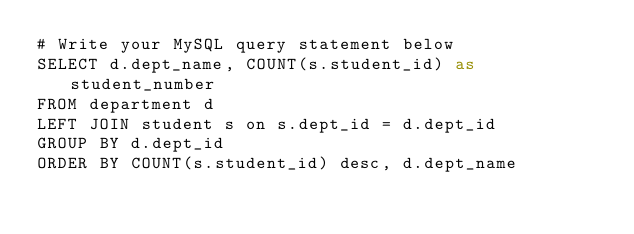<code> <loc_0><loc_0><loc_500><loc_500><_SQL_># Write your MySQL query statement below
SELECT d.dept_name, COUNT(s.student_id) as student_number
FROM department d
LEFT JOIN student s on s.dept_id = d.dept_id
GROUP BY d.dept_id
ORDER BY COUNT(s.student_id) desc, d.dept_name
</code> 